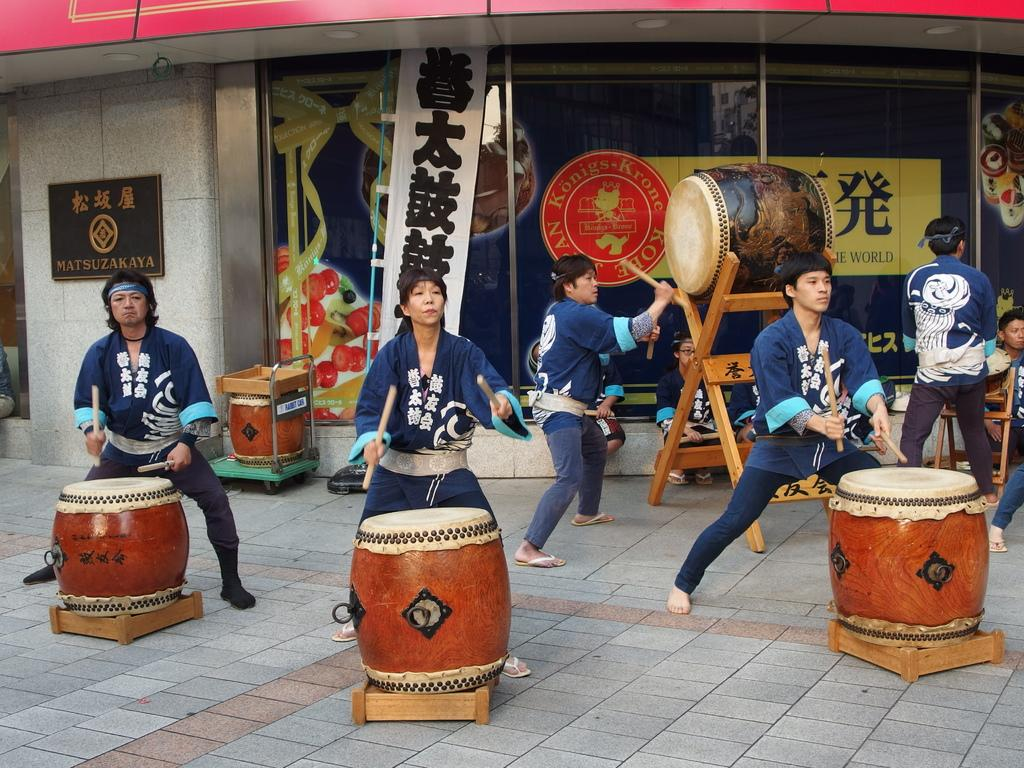What is happening in the image involving a group of people? There is a band of people in the image, and they are playing drums. Where is the band located? The band is located on a footpath. What else can be seen in the image? There is a store visible in the image. How many balls are being juggled by the band members in the image? There are no balls visible in the image; the band members are playing drums. 